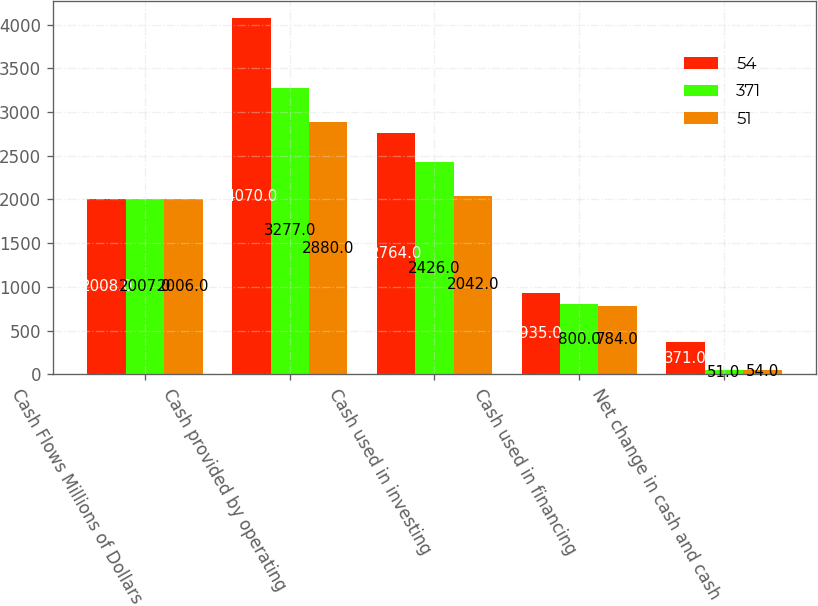Convert chart. <chart><loc_0><loc_0><loc_500><loc_500><stacked_bar_chart><ecel><fcel>Cash Flows Millions of Dollars<fcel>Cash provided by operating<fcel>Cash used in investing<fcel>Cash used in financing<fcel>Net change in cash and cash<nl><fcel>54<fcel>2008<fcel>4070<fcel>2764<fcel>935<fcel>371<nl><fcel>371<fcel>2007<fcel>3277<fcel>2426<fcel>800<fcel>51<nl><fcel>51<fcel>2006<fcel>2880<fcel>2042<fcel>784<fcel>54<nl></chart> 